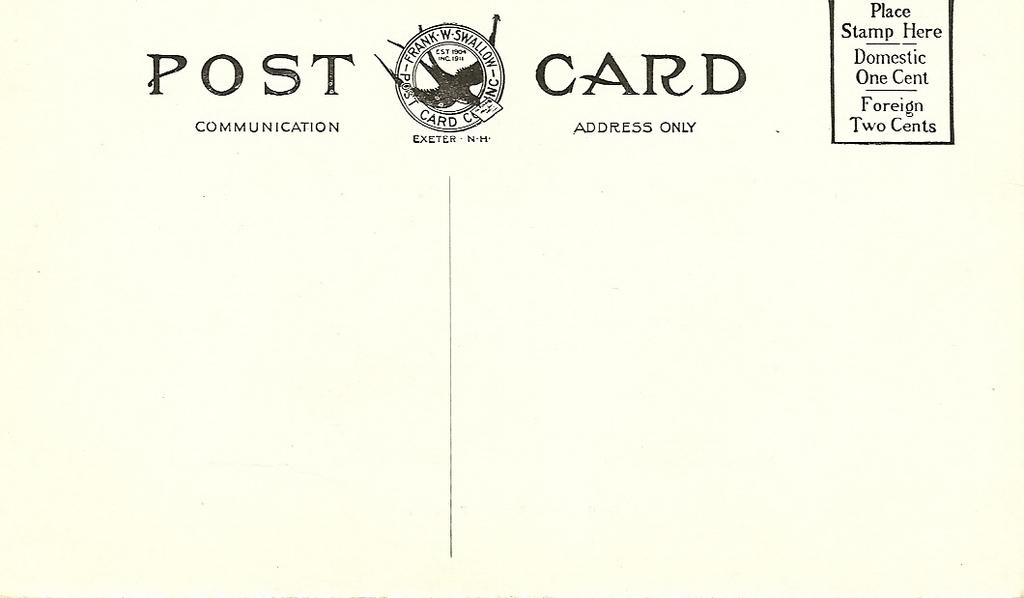<image>
Share a concise interpretation of the image provided. The blank back side of a post card from Exeter, NH. 